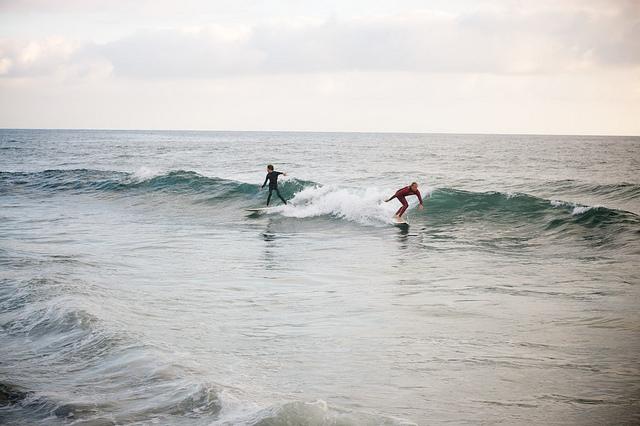How many people are in this photo?
Quick response, please. 2. Is she falling?
Quick response, please. No. Is the water still?
Write a very short answer. No. Are they both standing on the surfboard?
Short answer required. Yes. Are boats in the water?
Short answer required. No. Are there clouds?
Concise answer only. Yes. Are the surfers wearing identical wetsuits?
Quick response, please. No. What is in the water?
Keep it brief. Surfers. 